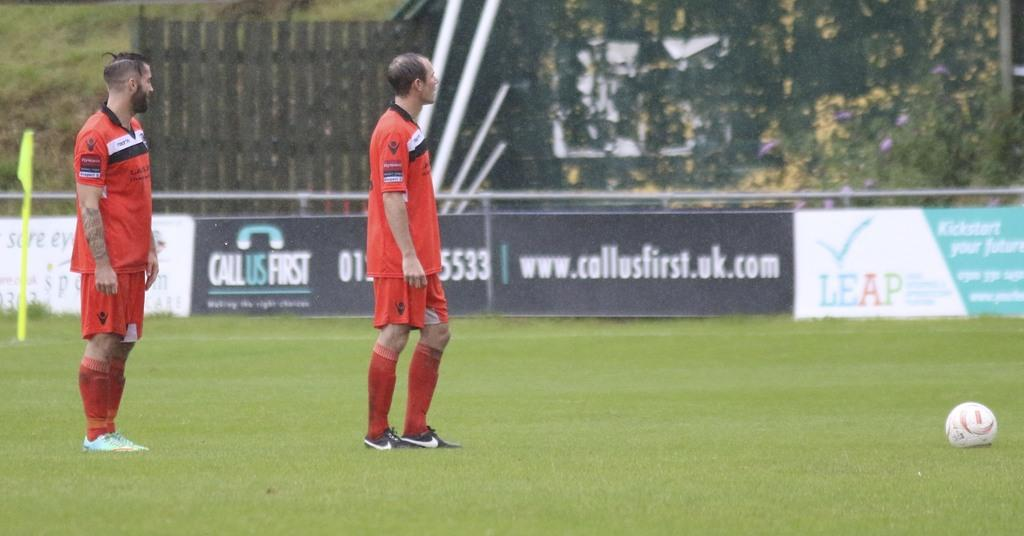<image>
Share a concise interpretation of the image provided. Two soccer players standing next to a ball with an ad for call us first in the background. 